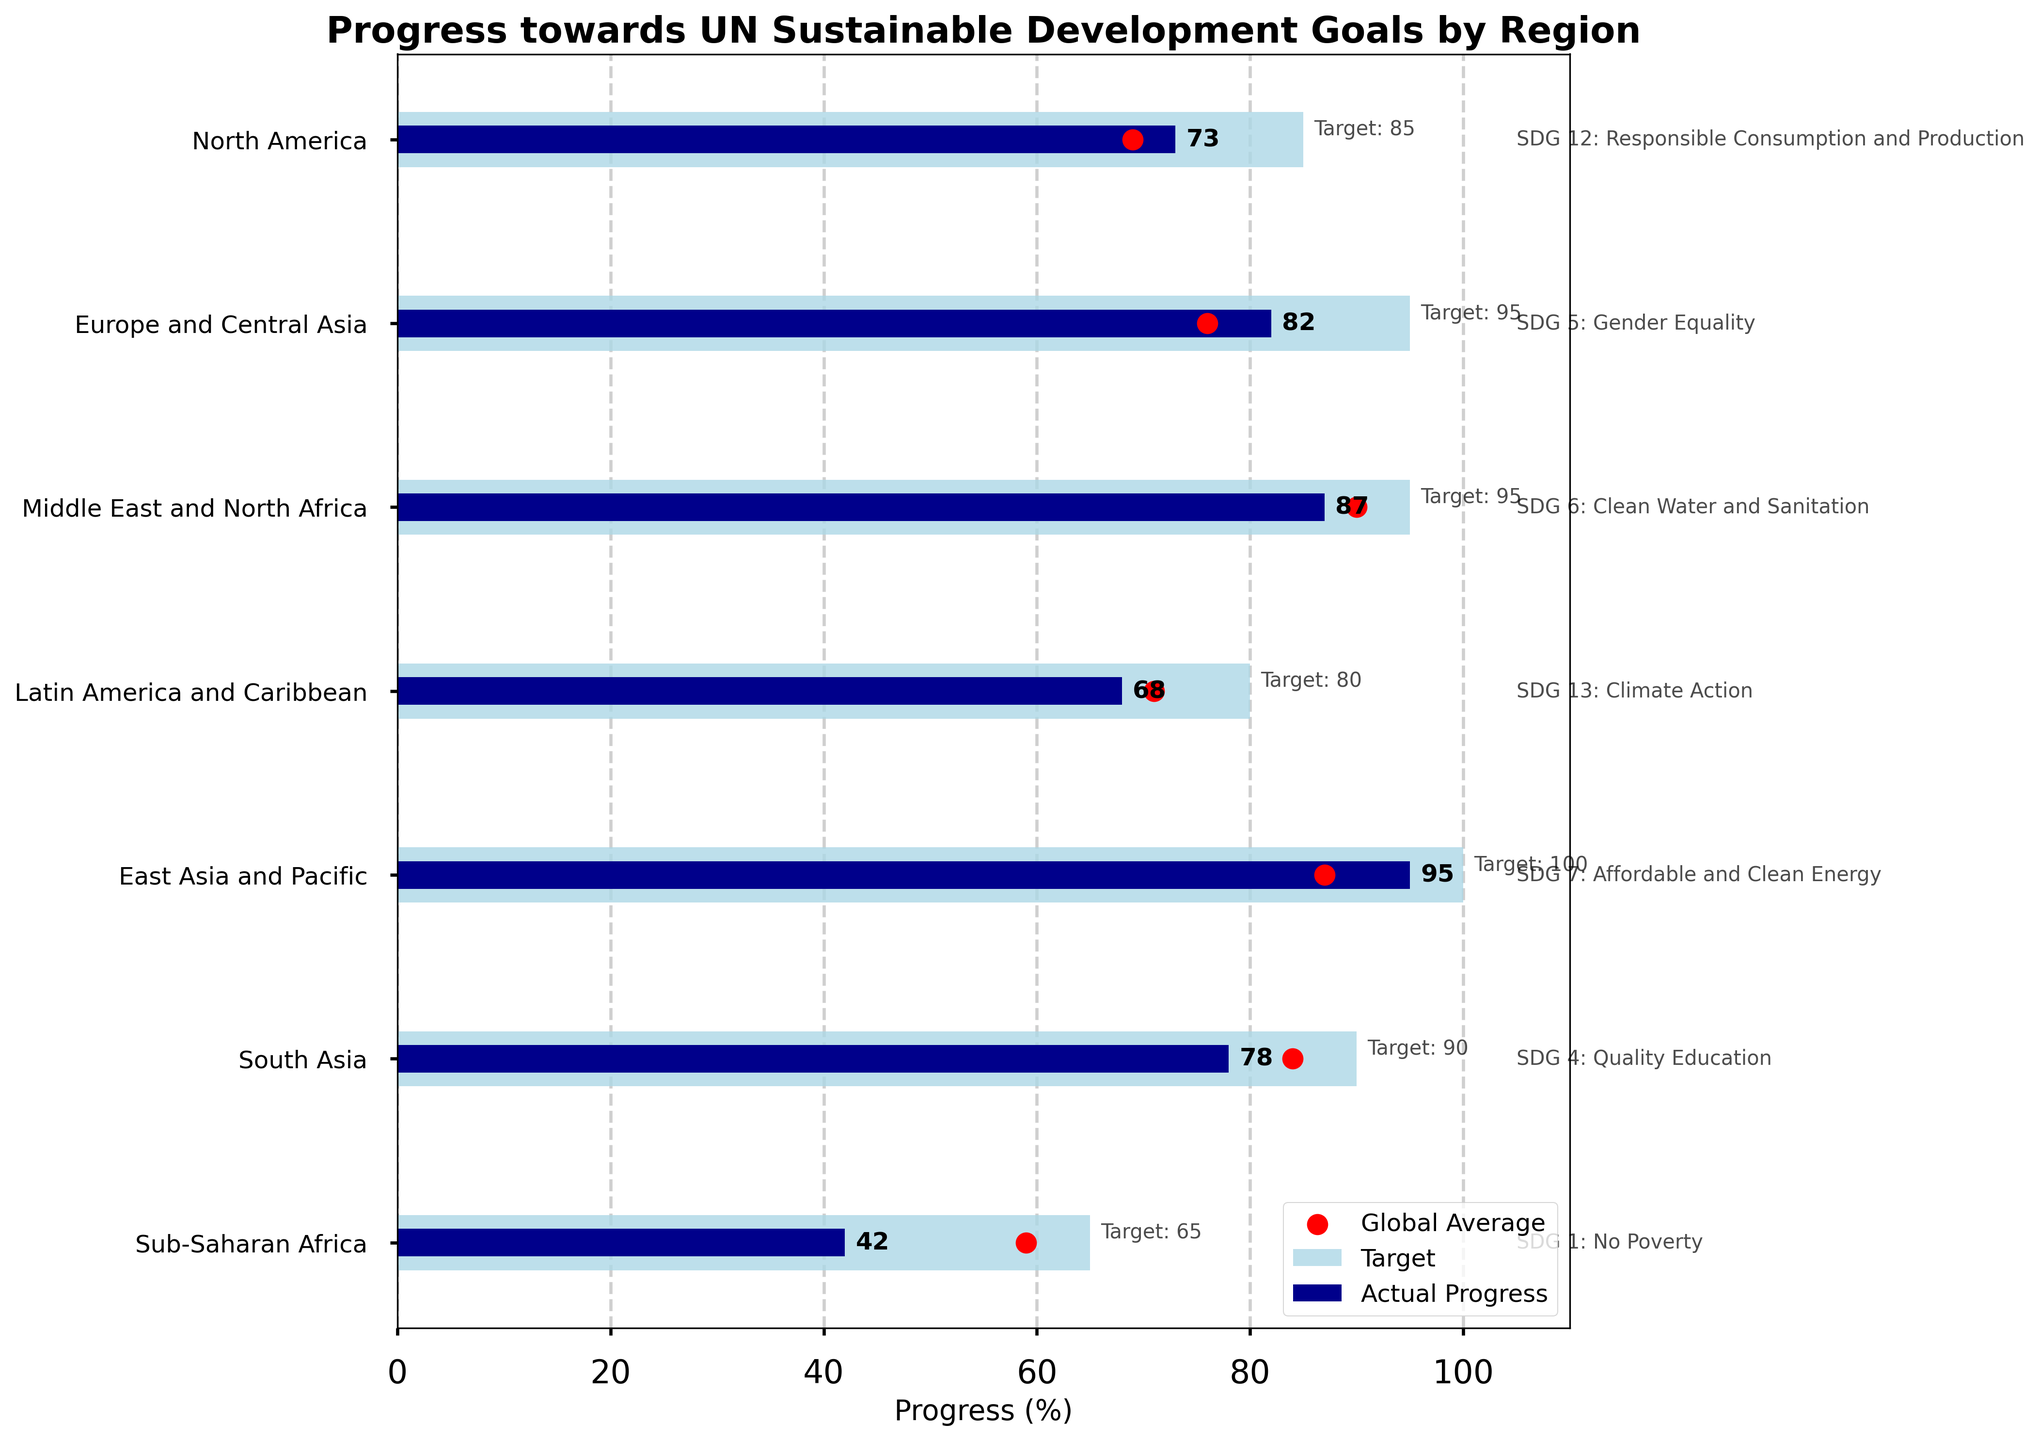How many regions are represented in the chart? Count the number of different regions listed on the y-axis.
Answer: 7 What is the title of the chart? Look at the text at the top of the chart.
Answer: Progress towards UN Sustainable Development Goals by Region Which region has the highest actual progress? Compare the actual progress bars for each region.
Answer: East Asia and Pacific What is the actual progress percentage for Sub-Saharan Africa towards "No Poverty"? Look at the bar corresponding to Sub-Saharan Africa and check the value labeled "Actual Progress".
Answer: 42% How does the actual progress of North America in "Responsible Consumption and Production" compare to the global average? Compare the actual progress bar for North America with the red dot representing the global average for the same SDG.
Answer: 73% vs 69% What is the difference between the target and actual progress for "Gender Equality" in Europe and Central Asia? Subtract the actual progress from the target for Europe and Central Asia in the "Gender Equality" SDG.
Answer: 95 - 82 = 13 Which SDG does South Asia have the progress data for, and what does the actual progress percentage look like? Check the label and value of the goal associated with South Asia.
Answer: SDG 4: Quality Education, 78% How many regions have an actual progress higher than the global average for their specific SDG? Compare the actual progress bar with the red dot for each region and count how many bars are higher.
Answer: 4 regions Which SDG has the smallest difference between the target and actual progress for the region it is associated with? Calculate the difference between target and actual progress for each region and find the smallest one.
Answer: SDG 7: Affordable and Clean Energy (East Asia and Pacific) with a difference of 5 What is the target progress percentage for Climate Action in Latin America and Caribbean? Look at the value labeled "Target" corresponding to Latin America and Caribbean in the "Climate Action" SDG.
Answer: 80% 